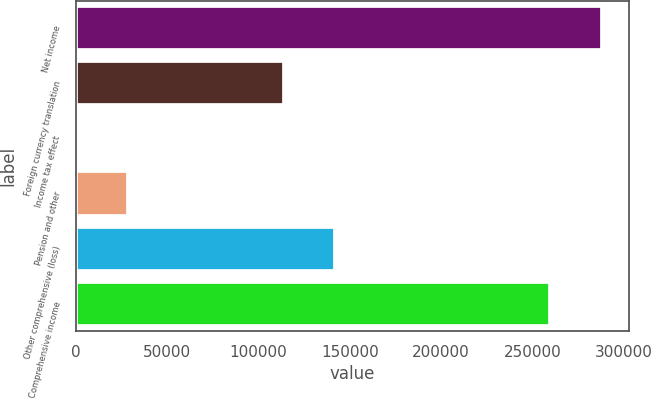Convert chart to OTSL. <chart><loc_0><loc_0><loc_500><loc_500><bar_chart><fcel>Net income<fcel>Foreign currency translation<fcel>Income tax effect<fcel>Pension and other<fcel>Other comprehensive (loss)<fcel>Comprehensive income<nl><fcel>288190<fcel>113724<fcel>132<fcel>28530.1<fcel>142122<fcel>259792<nl></chart> 